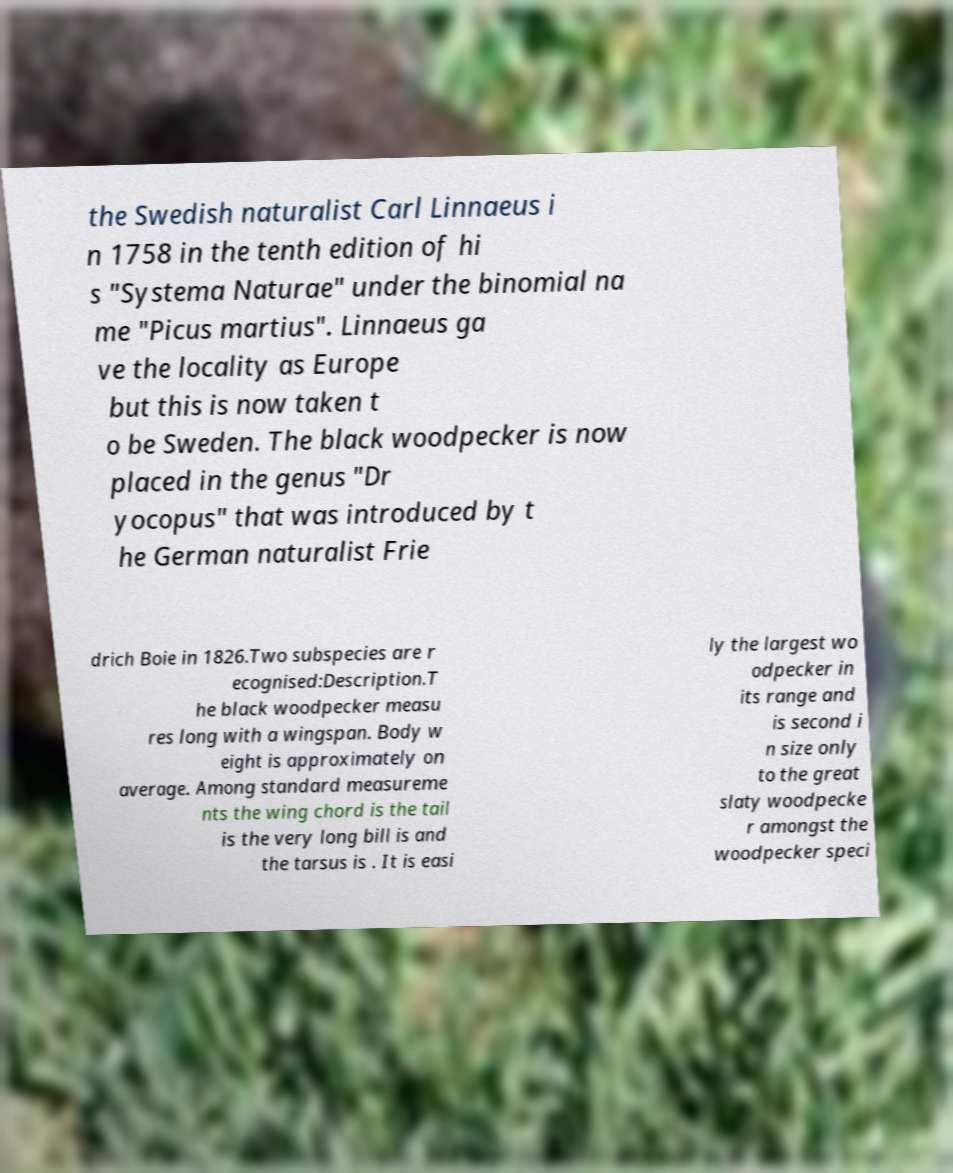I need the written content from this picture converted into text. Can you do that? the Swedish naturalist Carl Linnaeus i n 1758 in the tenth edition of hi s "Systema Naturae" under the binomial na me "Picus martius". Linnaeus ga ve the locality as Europe but this is now taken t o be Sweden. The black woodpecker is now placed in the genus "Dr yocopus" that was introduced by t he German naturalist Frie drich Boie in 1826.Two subspecies are r ecognised:Description.T he black woodpecker measu res long with a wingspan. Body w eight is approximately on average. Among standard measureme nts the wing chord is the tail is the very long bill is and the tarsus is . It is easi ly the largest wo odpecker in its range and is second i n size only to the great slaty woodpecke r amongst the woodpecker speci 